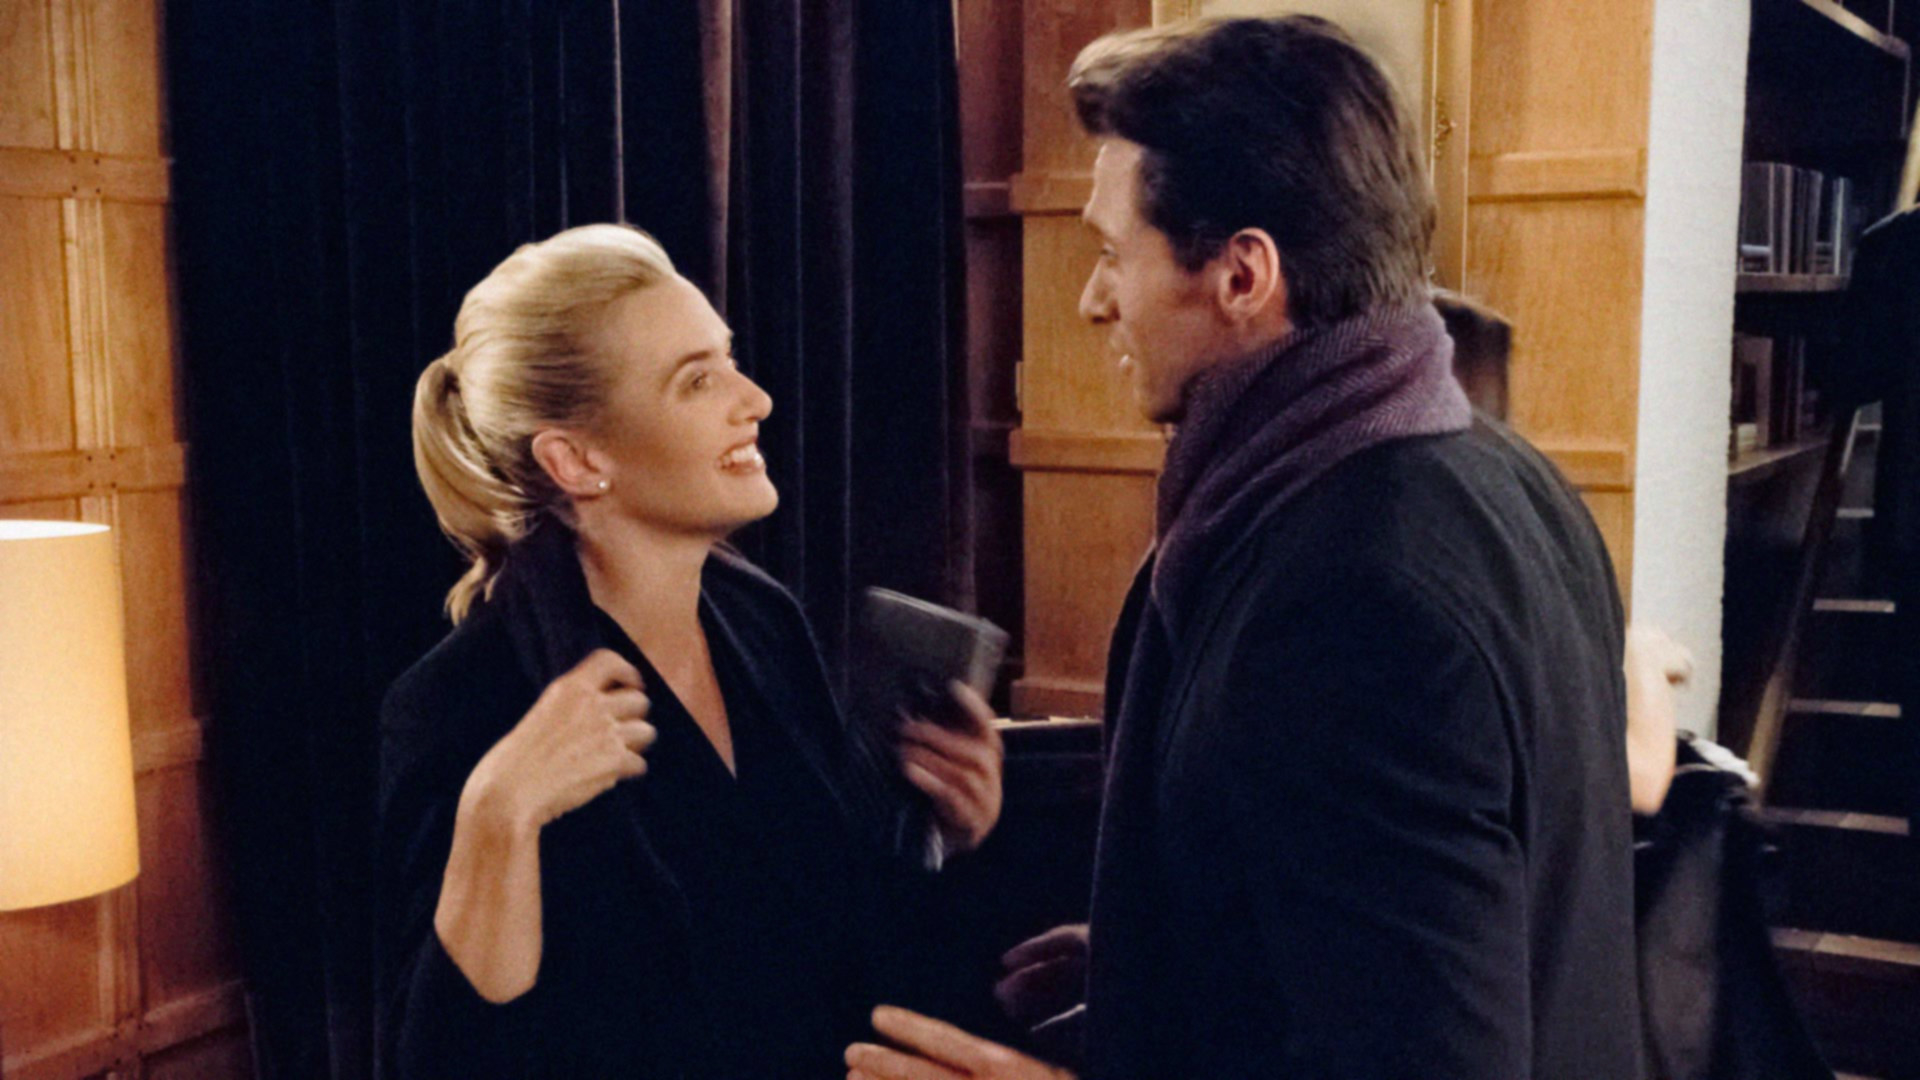What do you think is going on in this snapshot?
 In this image, the renowned actress Kate Winslet is captured in a scene from a movie. She stands in front of a wooden bookcase, her attire a chic black coat, and her hair elegantly styled into a bun. To her right stands an unidentified male actor, clad in a gray coat and a scarf, with a book held in his hand. The setting suggests a library or study room. Kate's gaze is directed upwards towards the male actor, her face adorned with a warm smile. The scene exudes an air of intellectual conversation and camaraderie. 